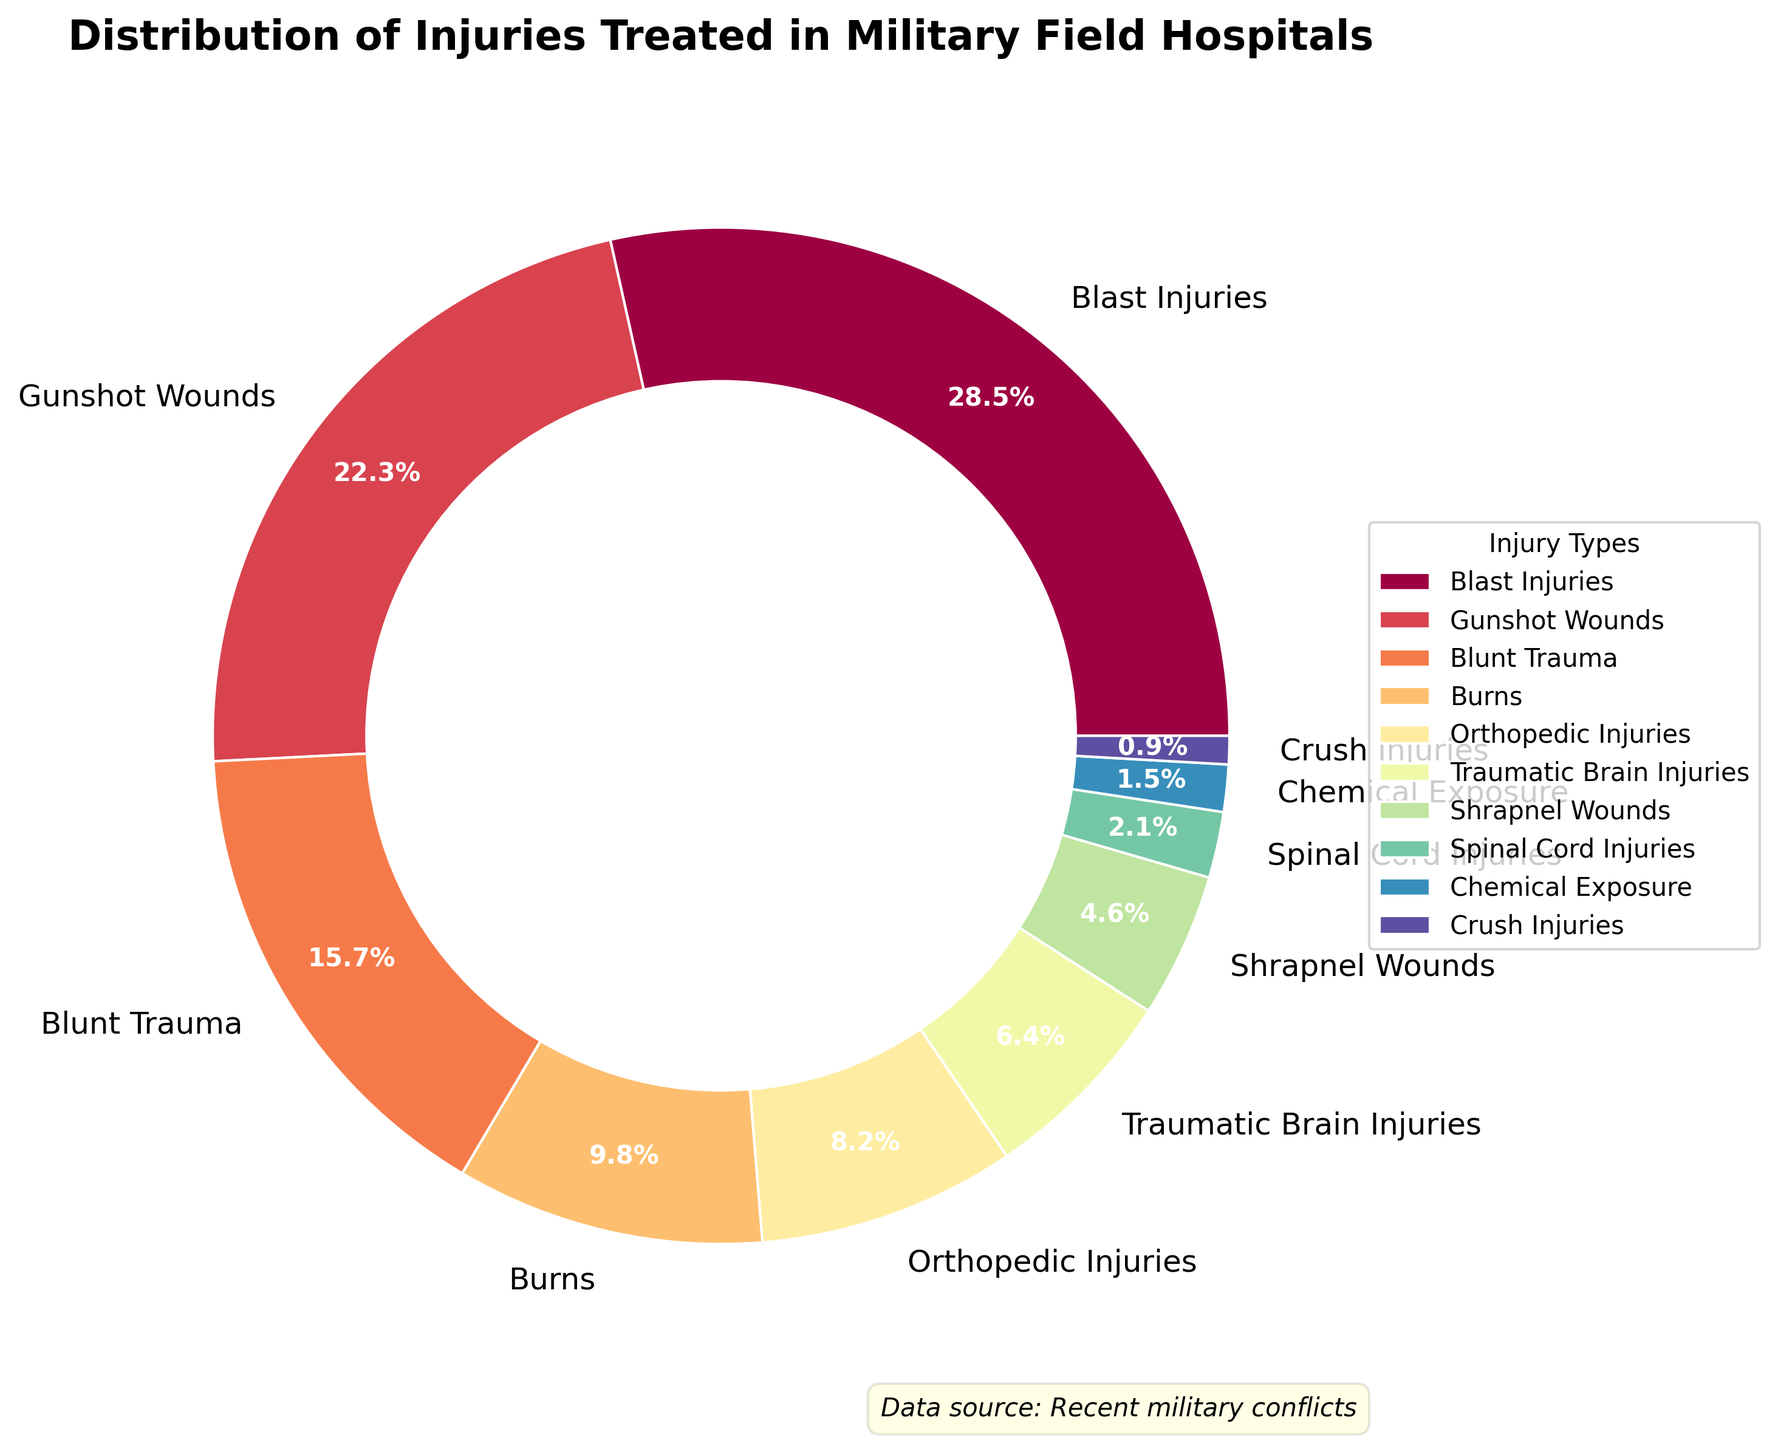Which injury type has the highest percentage distribution? The chart shows the percentage distribution of each injury type. By looking at the chart, we can see that Blast Injuries have the highest percentage, which is 28.5%.
Answer: Blast Injuries (28.5%) Which injury type has the lowest percentage distribution? The chart shows the percentage distribution of each injury type. Crush Injuries have the lowest percentage, which is 0.9%.
Answer: Crush Injuries (0.9%) What is the combined percentage of Gunshot Wounds and Blunt Trauma? The chart provides individual percentages for each type of injury. By summing the percentages of Gunshot Wounds and Blunt Trauma: 22.3% + 15.7% = 38%.
Answer: 38% Which injury type has a higher percentage, Burns or Orthopedic Injuries? To determine which type has a higher percentage, we compare the percentages of the two types. Burns have 9.8% while Orthopedic Injuries have 8.2%. Thus, Burns have a higher percentage.
Answer: Burns What is the total percentage of injuries related to projectiles (Gunshot Wounds and Shrapnel Wounds)? By adding the percentages of Gunshot Wounds and Shrapnel Wounds: 22.3% + 4.6% = 26.9%.
Answer: 26.9% How does the percentage of Traumatic Brain Injuries compare to Chemical Exposure? The chart shows that Traumatic Brain Injuries have a percentage of 6.4%. Chemical Exposure has a percentage of 1.5%. Thus, Traumatic Brain Injuries have a higher percentage.
Answer: Traumatic Brain Injuries What is the difference in percentage between Blast Injuries and Traumatic Brain Injuries? The chart shows Blast Injuries at 28.5% and Traumatic Brain Injuries at 6.4%. The difference is calculated by subtracting the smaller percentage from the larger: 28.5% - 6.4% = 22.1%.
Answer: 22.1% What percentage of injuries are due to blunt forces (Blunt Trauma and Crush Injuries)? Sum the percentages of Blunt Trauma and Crush Injuries: 15.7% + 0.9% = 16.6%.
Answer: 16.6% Which injuries have a percentage between 5% and 10%? Looking at the chart, the injuries with percentages in this range are Burns (9.8%), Orthopedic Injuries (8.2%), and Traumatic Brain Injuries (6.4%).
Answer: Burns, Orthopedic Injuries, Traumatic Brain Injuries Is the percentage of Spinal Cord Injuries greater than, less than, or equal to the percentage of Chemical Exposure? The chart shows Spinal Cord Injuries at 2.1% and Chemical Exposure at 1.5%. Therefore, Spinal Cord Injuries are greater.
Answer: Greater 